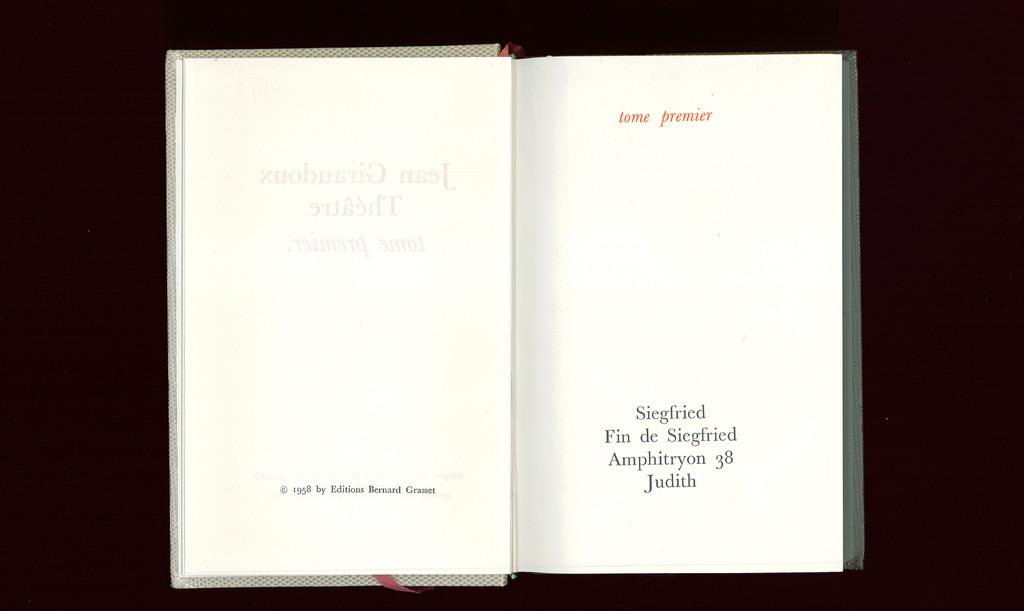<image>
Render a clear and concise summary of the photo. an open book titled Tome Premier and copyrighted in 1958 